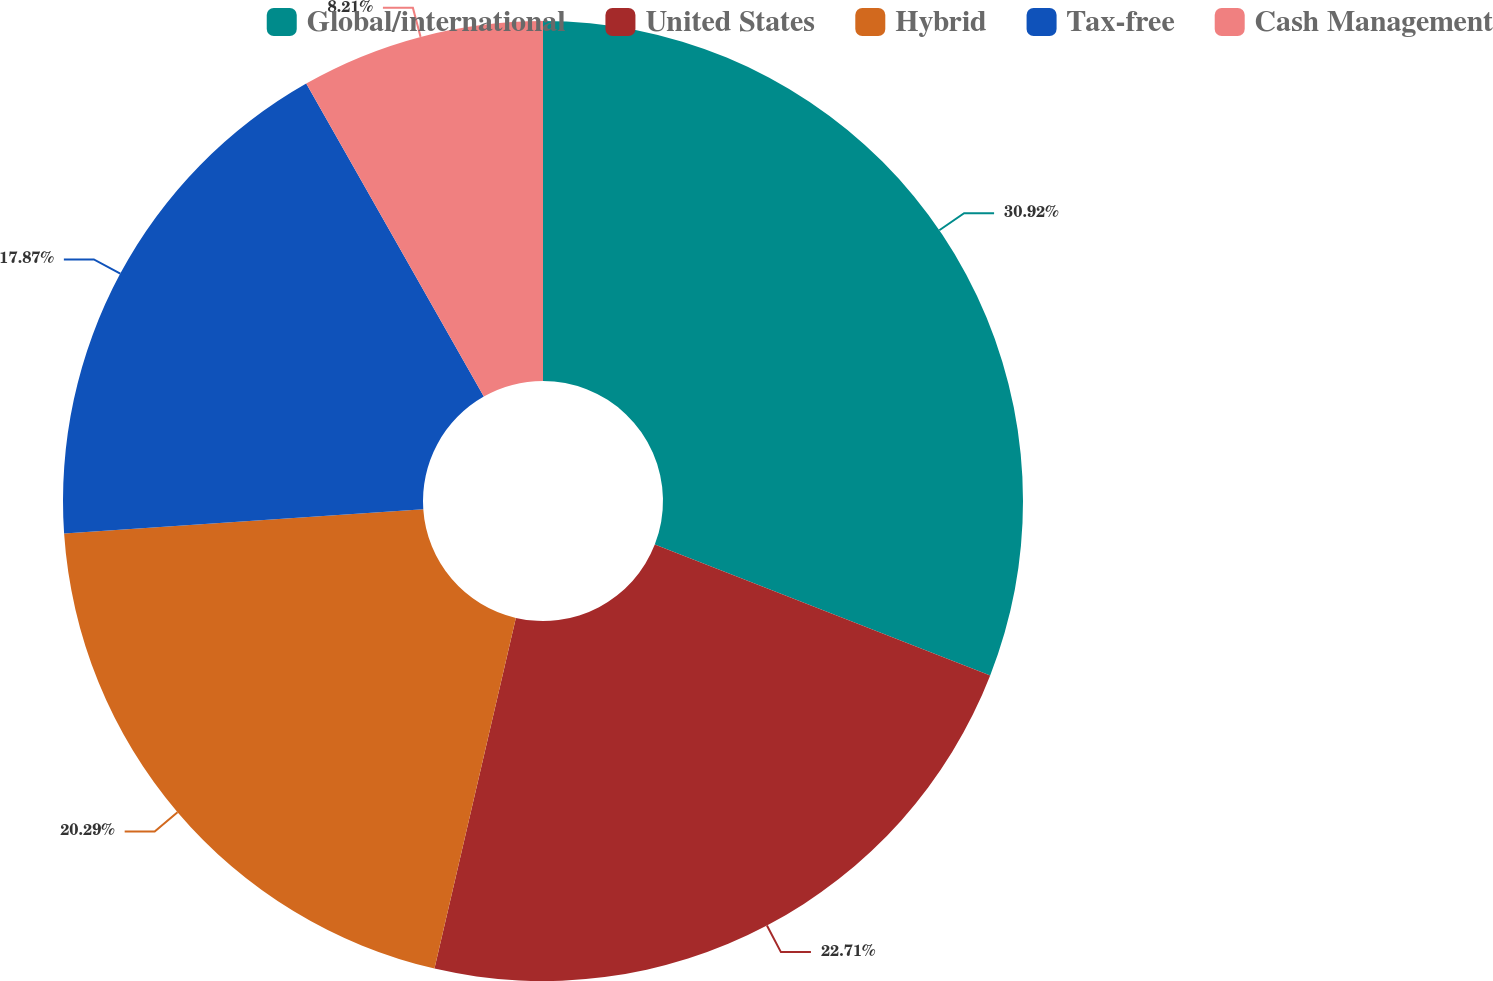Convert chart to OTSL. <chart><loc_0><loc_0><loc_500><loc_500><pie_chart><fcel>Global/international<fcel>United States<fcel>Hybrid<fcel>Tax-free<fcel>Cash Management<nl><fcel>30.92%<fcel>22.71%<fcel>20.29%<fcel>17.87%<fcel>8.21%<nl></chart> 